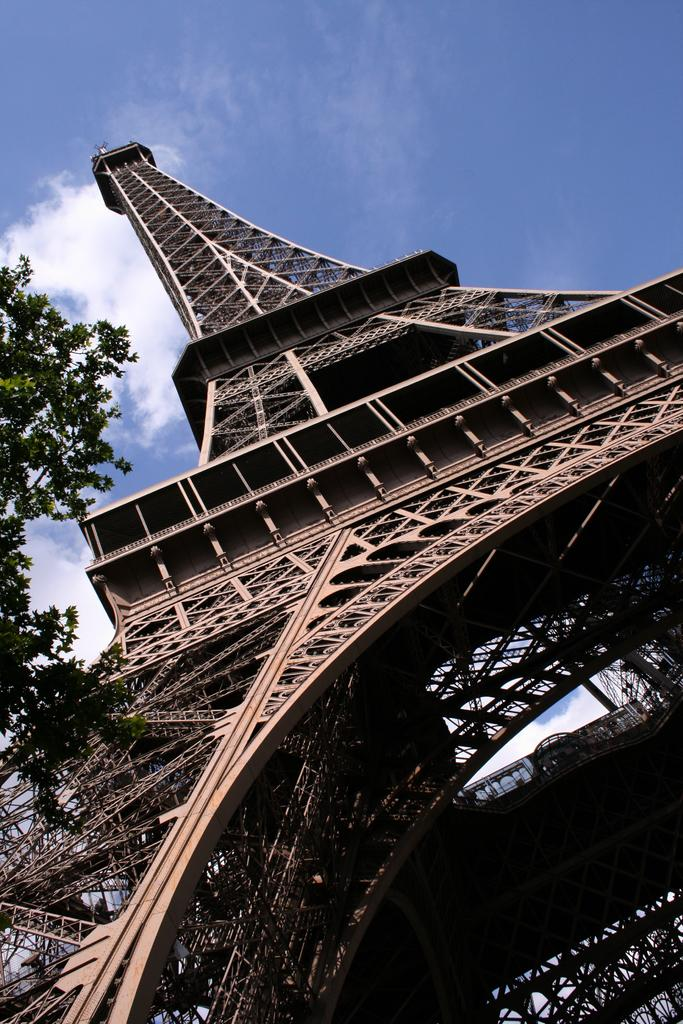What famous landmark can be seen in the image? The Eiffel tower is visible in the image. What type of vegetation is present in the image? There is a tree in the image. What part of the natural environment is visible in the image? The sky is visible in the image. What can be observed in the sky? Clouds are present in the sky. How many frogs are sitting on the branches of the tree in the image? There are no frogs present in the image; it only features the Eiffel tower, a tree, and clouds in the sky. 